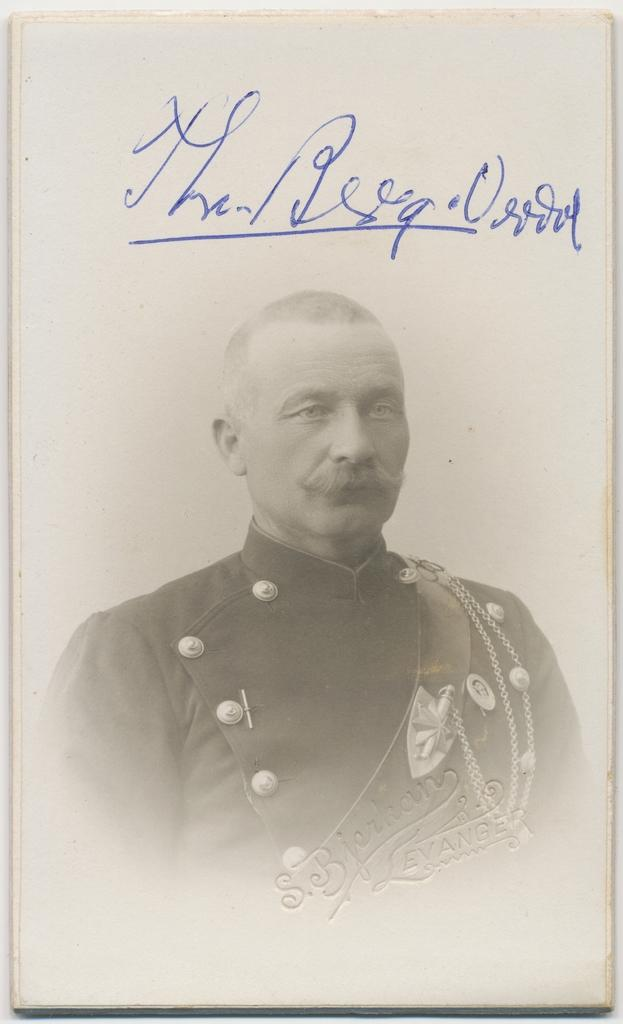What is the main subject of the image? The main subject of the image is a photograph of a man. Can you describe any additional details about the photograph? Yes, there is something written on the photograph. What type of cart can be seen on the edge of the photograph? There is no cart present on the edge of the photograph; it only features a man and some writing. 